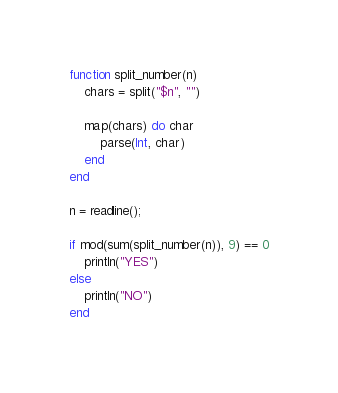Convert code to text. <code><loc_0><loc_0><loc_500><loc_500><_Julia_>function split_number(n)
    chars = split("$n", "")

    map(chars) do char
        parse(Int, char)
    end
end

n = readline();

if mod(sum(split_number(n)), 9) == 0
    println("YES")
else
    println("NO")
end</code> 